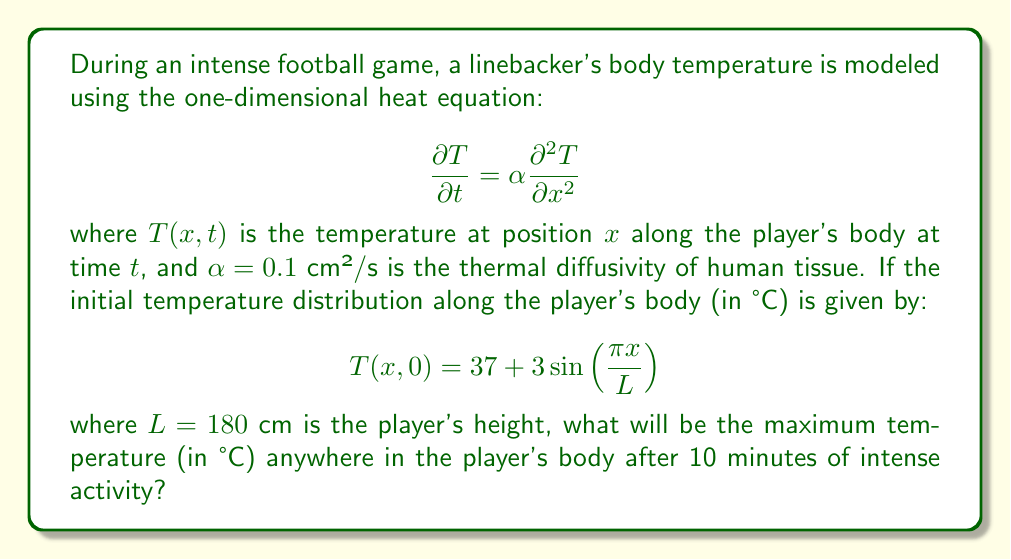Can you solve this math problem? Let's approach this step-by-step:

1) The general solution to the one-dimensional heat equation with the given initial condition is:

   $$T(x,t) = 37 + 3e^{-\alpha (\frac{\pi}{L})^2 t} \sin(\frac{\pi x}{L})$$

2) We need to find the maximum temperature after 10 minutes (600 seconds). This will occur at the point where $\sin(\frac{\pi x}{L})$ is at its maximum, which is 1.

3) So, we need to evaluate:

   $$T_{max}(t) = 37 + 3e^{-\alpha (\frac{\pi}{L})^2 t}$$

4) Let's substitute the given values:
   $\alpha = 0.1$ cm²/s
   $L = 180$ cm
   $t = 600$ s

5) Calculating:

   $$T_{max}(600) = 37 + 3e^{-0.1 (\frac{\pi}{180})^2 600}$$

6) Simplifying the exponent:

   $$(\frac{\pi}{180})^2 = 0.000304$$

   $$0.1 \times 0.000304 \times 600 = 0.01824$$

7) Therefore:

   $$T_{max}(600) = 37 + 3e^{-0.01824} = 37 + 3 \times 0.9819 = 39.9457$$

8) Rounding to two decimal places:

   $$T_{max}(600) \approx 39.95°C$$
Answer: 39.95°C 